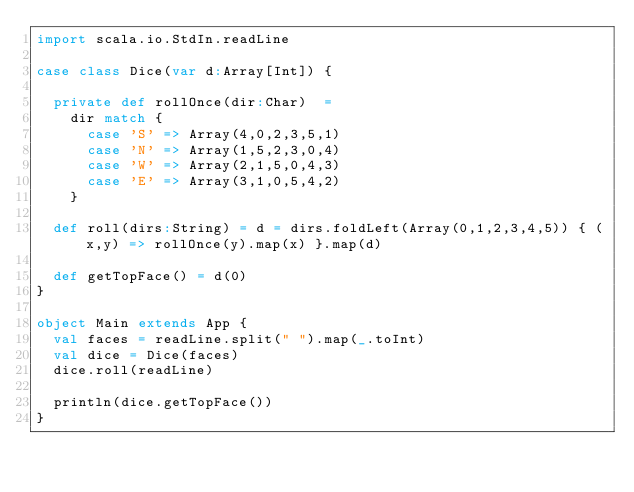Convert code to text. <code><loc_0><loc_0><loc_500><loc_500><_Scala_>import scala.io.StdIn.readLine

case class Dice(var d:Array[Int]) {

  private def rollOnce(dir:Char)  =
    dir match {
      case 'S' => Array(4,0,2,3,5,1)
      case 'N' => Array(1,5,2,3,0,4)
      case 'W' => Array(2,1,5,0,4,3)
      case 'E' => Array(3,1,0,5,4,2)
    }

  def roll(dirs:String) = d = dirs.foldLeft(Array(0,1,2,3,4,5)) { (x,y) => rollOnce(y).map(x) }.map(d)

  def getTopFace() = d(0)
}

object Main extends App {
  val faces = readLine.split(" ").map(_.toInt)
  val dice = Dice(faces)
  dice.roll(readLine)

  println(dice.getTopFace())
}</code> 